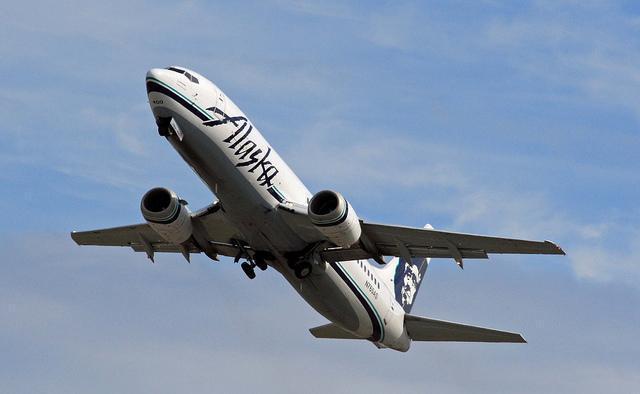How many engines does the plane have?
Give a very brief answer. 2. How many airplanes are there?
Give a very brief answer. 1. How many people have glasses?
Give a very brief answer. 0. 